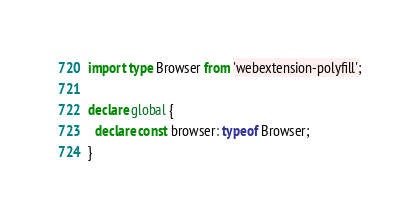<code> <loc_0><loc_0><loc_500><loc_500><_TypeScript_>import type Browser from 'webextension-polyfill';

declare global {
  declare const browser: typeof Browser;
}
</code> 